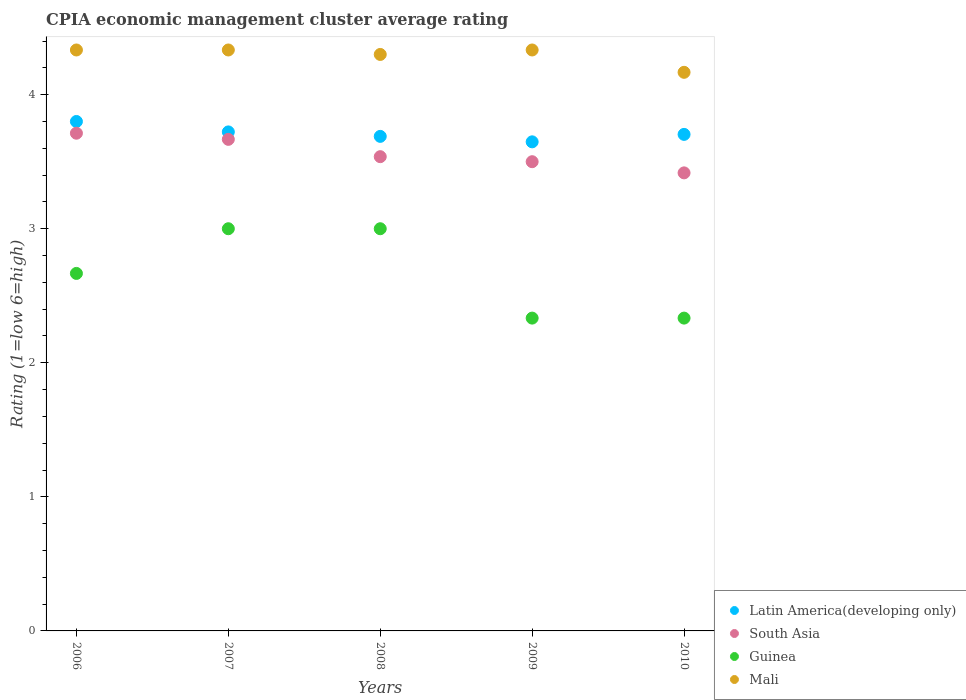How many different coloured dotlines are there?
Offer a very short reply. 4. What is the CPIA rating in Mali in 2006?
Offer a very short reply. 4.33. Across all years, what is the minimum CPIA rating in Mali?
Give a very brief answer. 4.17. In which year was the CPIA rating in Latin America(developing only) maximum?
Provide a short and direct response. 2006. What is the total CPIA rating in Guinea in the graph?
Ensure brevity in your answer.  13.33. What is the difference between the CPIA rating in Latin America(developing only) in 2006 and that in 2010?
Keep it short and to the point. 0.1. What is the difference between the CPIA rating in Guinea in 2007 and the CPIA rating in Latin America(developing only) in 2008?
Provide a succinct answer. -0.69. What is the average CPIA rating in Guinea per year?
Keep it short and to the point. 2.67. In the year 2007, what is the difference between the CPIA rating in Guinea and CPIA rating in South Asia?
Make the answer very short. -0.67. What is the ratio of the CPIA rating in Guinea in 2007 to that in 2009?
Your answer should be very brief. 1.29. What is the difference between the highest and the second highest CPIA rating in Latin America(developing only)?
Your answer should be compact. 0.08. What is the difference between the highest and the lowest CPIA rating in Latin America(developing only)?
Ensure brevity in your answer.  0.15. In how many years, is the CPIA rating in Guinea greater than the average CPIA rating in Guinea taken over all years?
Keep it short and to the point. 3. Is the sum of the CPIA rating in South Asia in 2007 and 2008 greater than the maximum CPIA rating in Guinea across all years?
Ensure brevity in your answer.  Yes. Is it the case that in every year, the sum of the CPIA rating in Mali and CPIA rating in South Asia  is greater than the sum of CPIA rating in Latin America(developing only) and CPIA rating in Guinea?
Ensure brevity in your answer.  Yes. Is the CPIA rating in Latin America(developing only) strictly greater than the CPIA rating in South Asia over the years?
Your answer should be very brief. Yes. What is the difference between two consecutive major ticks on the Y-axis?
Give a very brief answer. 1. Does the graph contain any zero values?
Provide a succinct answer. No. Does the graph contain grids?
Provide a succinct answer. No. How many legend labels are there?
Give a very brief answer. 4. How are the legend labels stacked?
Offer a terse response. Vertical. What is the title of the graph?
Keep it short and to the point. CPIA economic management cluster average rating. Does "Europe(all income levels)" appear as one of the legend labels in the graph?
Keep it short and to the point. No. What is the label or title of the X-axis?
Make the answer very short. Years. What is the Rating (1=low 6=high) of South Asia in 2006?
Your answer should be very brief. 3.71. What is the Rating (1=low 6=high) in Guinea in 2006?
Your answer should be very brief. 2.67. What is the Rating (1=low 6=high) of Mali in 2006?
Offer a terse response. 4.33. What is the Rating (1=low 6=high) in Latin America(developing only) in 2007?
Offer a terse response. 3.72. What is the Rating (1=low 6=high) of South Asia in 2007?
Provide a short and direct response. 3.67. What is the Rating (1=low 6=high) of Guinea in 2007?
Give a very brief answer. 3. What is the Rating (1=low 6=high) in Mali in 2007?
Offer a terse response. 4.33. What is the Rating (1=low 6=high) of Latin America(developing only) in 2008?
Provide a succinct answer. 3.69. What is the Rating (1=low 6=high) in South Asia in 2008?
Ensure brevity in your answer.  3.54. What is the Rating (1=low 6=high) in Guinea in 2008?
Provide a short and direct response. 3. What is the Rating (1=low 6=high) of Mali in 2008?
Your response must be concise. 4.3. What is the Rating (1=low 6=high) in Latin America(developing only) in 2009?
Offer a very short reply. 3.65. What is the Rating (1=low 6=high) of South Asia in 2009?
Provide a succinct answer. 3.5. What is the Rating (1=low 6=high) of Guinea in 2009?
Provide a succinct answer. 2.33. What is the Rating (1=low 6=high) of Mali in 2009?
Ensure brevity in your answer.  4.33. What is the Rating (1=low 6=high) in Latin America(developing only) in 2010?
Offer a very short reply. 3.7. What is the Rating (1=low 6=high) of South Asia in 2010?
Your answer should be very brief. 3.42. What is the Rating (1=low 6=high) in Guinea in 2010?
Your response must be concise. 2.33. What is the Rating (1=low 6=high) in Mali in 2010?
Offer a very short reply. 4.17. Across all years, what is the maximum Rating (1=low 6=high) in South Asia?
Your response must be concise. 3.71. Across all years, what is the maximum Rating (1=low 6=high) of Guinea?
Keep it short and to the point. 3. Across all years, what is the maximum Rating (1=low 6=high) in Mali?
Provide a succinct answer. 4.33. Across all years, what is the minimum Rating (1=low 6=high) of Latin America(developing only)?
Give a very brief answer. 3.65. Across all years, what is the minimum Rating (1=low 6=high) of South Asia?
Give a very brief answer. 3.42. Across all years, what is the minimum Rating (1=low 6=high) in Guinea?
Provide a succinct answer. 2.33. Across all years, what is the minimum Rating (1=low 6=high) of Mali?
Offer a terse response. 4.17. What is the total Rating (1=low 6=high) in Latin America(developing only) in the graph?
Give a very brief answer. 18.56. What is the total Rating (1=low 6=high) of South Asia in the graph?
Your response must be concise. 17.83. What is the total Rating (1=low 6=high) in Guinea in the graph?
Your response must be concise. 13.33. What is the total Rating (1=low 6=high) of Mali in the graph?
Your response must be concise. 21.47. What is the difference between the Rating (1=low 6=high) of Latin America(developing only) in 2006 and that in 2007?
Provide a short and direct response. 0.08. What is the difference between the Rating (1=low 6=high) of South Asia in 2006 and that in 2007?
Keep it short and to the point. 0.05. What is the difference between the Rating (1=low 6=high) in Guinea in 2006 and that in 2007?
Offer a terse response. -0.33. What is the difference between the Rating (1=low 6=high) of Latin America(developing only) in 2006 and that in 2008?
Your answer should be very brief. 0.11. What is the difference between the Rating (1=low 6=high) of South Asia in 2006 and that in 2008?
Keep it short and to the point. 0.17. What is the difference between the Rating (1=low 6=high) of Guinea in 2006 and that in 2008?
Offer a very short reply. -0.33. What is the difference between the Rating (1=low 6=high) of Latin America(developing only) in 2006 and that in 2009?
Your answer should be very brief. 0.15. What is the difference between the Rating (1=low 6=high) in South Asia in 2006 and that in 2009?
Give a very brief answer. 0.21. What is the difference between the Rating (1=low 6=high) in Mali in 2006 and that in 2009?
Offer a terse response. 0. What is the difference between the Rating (1=low 6=high) in Latin America(developing only) in 2006 and that in 2010?
Offer a very short reply. 0.1. What is the difference between the Rating (1=low 6=high) of South Asia in 2006 and that in 2010?
Offer a terse response. 0.3. What is the difference between the Rating (1=low 6=high) in Guinea in 2006 and that in 2010?
Offer a very short reply. 0.33. What is the difference between the Rating (1=low 6=high) in South Asia in 2007 and that in 2008?
Offer a very short reply. 0.13. What is the difference between the Rating (1=low 6=high) in Mali in 2007 and that in 2008?
Give a very brief answer. 0.03. What is the difference between the Rating (1=low 6=high) in Latin America(developing only) in 2007 and that in 2009?
Ensure brevity in your answer.  0.07. What is the difference between the Rating (1=low 6=high) in Mali in 2007 and that in 2009?
Give a very brief answer. 0. What is the difference between the Rating (1=low 6=high) of Latin America(developing only) in 2007 and that in 2010?
Keep it short and to the point. 0.02. What is the difference between the Rating (1=low 6=high) in Guinea in 2007 and that in 2010?
Provide a succinct answer. 0.67. What is the difference between the Rating (1=low 6=high) in Latin America(developing only) in 2008 and that in 2009?
Your response must be concise. 0.04. What is the difference between the Rating (1=low 6=high) in South Asia in 2008 and that in 2009?
Give a very brief answer. 0.04. What is the difference between the Rating (1=low 6=high) of Mali in 2008 and that in 2009?
Your answer should be compact. -0.03. What is the difference between the Rating (1=low 6=high) in Latin America(developing only) in 2008 and that in 2010?
Keep it short and to the point. -0.01. What is the difference between the Rating (1=low 6=high) of South Asia in 2008 and that in 2010?
Your answer should be very brief. 0.12. What is the difference between the Rating (1=low 6=high) of Guinea in 2008 and that in 2010?
Provide a succinct answer. 0.67. What is the difference between the Rating (1=low 6=high) of Mali in 2008 and that in 2010?
Your response must be concise. 0.13. What is the difference between the Rating (1=low 6=high) of Latin America(developing only) in 2009 and that in 2010?
Make the answer very short. -0.06. What is the difference between the Rating (1=low 6=high) in South Asia in 2009 and that in 2010?
Make the answer very short. 0.08. What is the difference between the Rating (1=low 6=high) of Latin America(developing only) in 2006 and the Rating (1=low 6=high) of South Asia in 2007?
Provide a succinct answer. 0.13. What is the difference between the Rating (1=low 6=high) of Latin America(developing only) in 2006 and the Rating (1=low 6=high) of Guinea in 2007?
Provide a short and direct response. 0.8. What is the difference between the Rating (1=low 6=high) of Latin America(developing only) in 2006 and the Rating (1=low 6=high) of Mali in 2007?
Ensure brevity in your answer.  -0.53. What is the difference between the Rating (1=low 6=high) in South Asia in 2006 and the Rating (1=low 6=high) in Guinea in 2007?
Ensure brevity in your answer.  0.71. What is the difference between the Rating (1=low 6=high) in South Asia in 2006 and the Rating (1=low 6=high) in Mali in 2007?
Give a very brief answer. -0.62. What is the difference between the Rating (1=low 6=high) in Guinea in 2006 and the Rating (1=low 6=high) in Mali in 2007?
Keep it short and to the point. -1.67. What is the difference between the Rating (1=low 6=high) in Latin America(developing only) in 2006 and the Rating (1=low 6=high) in South Asia in 2008?
Keep it short and to the point. 0.26. What is the difference between the Rating (1=low 6=high) in Latin America(developing only) in 2006 and the Rating (1=low 6=high) in Guinea in 2008?
Offer a very short reply. 0.8. What is the difference between the Rating (1=low 6=high) in Latin America(developing only) in 2006 and the Rating (1=low 6=high) in Mali in 2008?
Offer a terse response. -0.5. What is the difference between the Rating (1=low 6=high) in South Asia in 2006 and the Rating (1=low 6=high) in Guinea in 2008?
Ensure brevity in your answer.  0.71. What is the difference between the Rating (1=low 6=high) of South Asia in 2006 and the Rating (1=low 6=high) of Mali in 2008?
Your answer should be compact. -0.59. What is the difference between the Rating (1=low 6=high) in Guinea in 2006 and the Rating (1=low 6=high) in Mali in 2008?
Make the answer very short. -1.63. What is the difference between the Rating (1=low 6=high) in Latin America(developing only) in 2006 and the Rating (1=low 6=high) in Guinea in 2009?
Make the answer very short. 1.47. What is the difference between the Rating (1=low 6=high) of Latin America(developing only) in 2006 and the Rating (1=low 6=high) of Mali in 2009?
Offer a terse response. -0.53. What is the difference between the Rating (1=low 6=high) of South Asia in 2006 and the Rating (1=low 6=high) of Guinea in 2009?
Make the answer very short. 1.38. What is the difference between the Rating (1=low 6=high) in South Asia in 2006 and the Rating (1=low 6=high) in Mali in 2009?
Provide a succinct answer. -0.62. What is the difference between the Rating (1=low 6=high) of Guinea in 2006 and the Rating (1=low 6=high) of Mali in 2009?
Your response must be concise. -1.67. What is the difference between the Rating (1=low 6=high) of Latin America(developing only) in 2006 and the Rating (1=low 6=high) of South Asia in 2010?
Offer a terse response. 0.38. What is the difference between the Rating (1=low 6=high) of Latin America(developing only) in 2006 and the Rating (1=low 6=high) of Guinea in 2010?
Keep it short and to the point. 1.47. What is the difference between the Rating (1=low 6=high) of Latin America(developing only) in 2006 and the Rating (1=low 6=high) of Mali in 2010?
Offer a terse response. -0.37. What is the difference between the Rating (1=low 6=high) of South Asia in 2006 and the Rating (1=low 6=high) of Guinea in 2010?
Ensure brevity in your answer.  1.38. What is the difference between the Rating (1=low 6=high) in South Asia in 2006 and the Rating (1=low 6=high) in Mali in 2010?
Your response must be concise. -0.45. What is the difference between the Rating (1=low 6=high) in Latin America(developing only) in 2007 and the Rating (1=low 6=high) in South Asia in 2008?
Your answer should be very brief. 0.18. What is the difference between the Rating (1=low 6=high) of Latin America(developing only) in 2007 and the Rating (1=low 6=high) of Guinea in 2008?
Offer a terse response. 0.72. What is the difference between the Rating (1=low 6=high) in Latin America(developing only) in 2007 and the Rating (1=low 6=high) in Mali in 2008?
Keep it short and to the point. -0.58. What is the difference between the Rating (1=low 6=high) of South Asia in 2007 and the Rating (1=low 6=high) of Mali in 2008?
Your response must be concise. -0.63. What is the difference between the Rating (1=low 6=high) of Latin America(developing only) in 2007 and the Rating (1=low 6=high) of South Asia in 2009?
Offer a very short reply. 0.22. What is the difference between the Rating (1=low 6=high) of Latin America(developing only) in 2007 and the Rating (1=low 6=high) of Guinea in 2009?
Offer a very short reply. 1.39. What is the difference between the Rating (1=low 6=high) of Latin America(developing only) in 2007 and the Rating (1=low 6=high) of Mali in 2009?
Offer a very short reply. -0.61. What is the difference between the Rating (1=low 6=high) of South Asia in 2007 and the Rating (1=low 6=high) of Mali in 2009?
Your response must be concise. -0.67. What is the difference between the Rating (1=low 6=high) of Guinea in 2007 and the Rating (1=low 6=high) of Mali in 2009?
Give a very brief answer. -1.33. What is the difference between the Rating (1=low 6=high) in Latin America(developing only) in 2007 and the Rating (1=low 6=high) in South Asia in 2010?
Your response must be concise. 0.31. What is the difference between the Rating (1=low 6=high) in Latin America(developing only) in 2007 and the Rating (1=low 6=high) in Guinea in 2010?
Provide a succinct answer. 1.39. What is the difference between the Rating (1=low 6=high) in Latin America(developing only) in 2007 and the Rating (1=low 6=high) in Mali in 2010?
Your response must be concise. -0.44. What is the difference between the Rating (1=low 6=high) in South Asia in 2007 and the Rating (1=low 6=high) in Mali in 2010?
Your response must be concise. -0.5. What is the difference between the Rating (1=low 6=high) of Guinea in 2007 and the Rating (1=low 6=high) of Mali in 2010?
Ensure brevity in your answer.  -1.17. What is the difference between the Rating (1=low 6=high) in Latin America(developing only) in 2008 and the Rating (1=low 6=high) in South Asia in 2009?
Your response must be concise. 0.19. What is the difference between the Rating (1=low 6=high) in Latin America(developing only) in 2008 and the Rating (1=low 6=high) in Guinea in 2009?
Your response must be concise. 1.36. What is the difference between the Rating (1=low 6=high) in Latin America(developing only) in 2008 and the Rating (1=low 6=high) in Mali in 2009?
Offer a very short reply. -0.64. What is the difference between the Rating (1=low 6=high) of South Asia in 2008 and the Rating (1=low 6=high) of Guinea in 2009?
Make the answer very short. 1.2. What is the difference between the Rating (1=low 6=high) of South Asia in 2008 and the Rating (1=low 6=high) of Mali in 2009?
Provide a succinct answer. -0.8. What is the difference between the Rating (1=low 6=high) in Guinea in 2008 and the Rating (1=low 6=high) in Mali in 2009?
Your response must be concise. -1.33. What is the difference between the Rating (1=low 6=high) of Latin America(developing only) in 2008 and the Rating (1=low 6=high) of South Asia in 2010?
Make the answer very short. 0.27. What is the difference between the Rating (1=low 6=high) in Latin America(developing only) in 2008 and the Rating (1=low 6=high) in Guinea in 2010?
Ensure brevity in your answer.  1.36. What is the difference between the Rating (1=low 6=high) in Latin America(developing only) in 2008 and the Rating (1=low 6=high) in Mali in 2010?
Your response must be concise. -0.48. What is the difference between the Rating (1=low 6=high) of South Asia in 2008 and the Rating (1=low 6=high) of Guinea in 2010?
Offer a very short reply. 1.2. What is the difference between the Rating (1=low 6=high) in South Asia in 2008 and the Rating (1=low 6=high) in Mali in 2010?
Your response must be concise. -0.63. What is the difference between the Rating (1=low 6=high) of Guinea in 2008 and the Rating (1=low 6=high) of Mali in 2010?
Your answer should be compact. -1.17. What is the difference between the Rating (1=low 6=high) of Latin America(developing only) in 2009 and the Rating (1=low 6=high) of South Asia in 2010?
Your response must be concise. 0.23. What is the difference between the Rating (1=low 6=high) of Latin America(developing only) in 2009 and the Rating (1=low 6=high) of Guinea in 2010?
Your answer should be very brief. 1.31. What is the difference between the Rating (1=low 6=high) of Latin America(developing only) in 2009 and the Rating (1=low 6=high) of Mali in 2010?
Your answer should be very brief. -0.52. What is the difference between the Rating (1=low 6=high) in South Asia in 2009 and the Rating (1=low 6=high) in Guinea in 2010?
Make the answer very short. 1.17. What is the difference between the Rating (1=low 6=high) of Guinea in 2009 and the Rating (1=low 6=high) of Mali in 2010?
Your answer should be compact. -1.83. What is the average Rating (1=low 6=high) of Latin America(developing only) per year?
Your answer should be compact. 3.71. What is the average Rating (1=low 6=high) in South Asia per year?
Provide a succinct answer. 3.57. What is the average Rating (1=low 6=high) of Guinea per year?
Ensure brevity in your answer.  2.67. What is the average Rating (1=low 6=high) of Mali per year?
Your answer should be very brief. 4.29. In the year 2006, what is the difference between the Rating (1=low 6=high) of Latin America(developing only) and Rating (1=low 6=high) of South Asia?
Ensure brevity in your answer.  0.09. In the year 2006, what is the difference between the Rating (1=low 6=high) of Latin America(developing only) and Rating (1=low 6=high) of Guinea?
Provide a short and direct response. 1.13. In the year 2006, what is the difference between the Rating (1=low 6=high) in Latin America(developing only) and Rating (1=low 6=high) in Mali?
Provide a short and direct response. -0.53. In the year 2006, what is the difference between the Rating (1=low 6=high) in South Asia and Rating (1=low 6=high) in Guinea?
Offer a terse response. 1.05. In the year 2006, what is the difference between the Rating (1=low 6=high) in South Asia and Rating (1=low 6=high) in Mali?
Provide a succinct answer. -0.62. In the year 2006, what is the difference between the Rating (1=low 6=high) in Guinea and Rating (1=low 6=high) in Mali?
Provide a succinct answer. -1.67. In the year 2007, what is the difference between the Rating (1=low 6=high) of Latin America(developing only) and Rating (1=low 6=high) of South Asia?
Ensure brevity in your answer.  0.06. In the year 2007, what is the difference between the Rating (1=low 6=high) in Latin America(developing only) and Rating (1=low 6=high) in Guinea?
Keep it short and to the point. 0.72. In the year 2007, what is the difference between the Rating (1=low 6=high) of Latin America(developing only) and Rating (1=low 6=high) of Mali?
Your response must be concise. -0.61. In the year 2007, what is the difference between the Rating (1=low 6=high) in South Asia and Rating (1=low 6=high) in Mali?
Keep it short and to the point. -0.67. In the year 2007, what is the difference between the Rating (1=low 6=high) of Guinea and Rating (1=low 6=high) of Mali?
Offer a terse response. -1.33. In the year 2008, what is the difference between the Rating (1=low 6=high) of Latin America(developing only) and Rating (1=low 6=high) of South Asia?
Ensure brevity in your answer.  0.15. In the year 2008, what is the difference between the Rating (1=low 6=high) in Latin America(developing only) and Rating (1=low 6=high) in Guinea?
Give a very brief answer. 0.69. In the year 2008, what is the difference between the Rating (1=low 6=high) in Latin America(developing only) and Rating (1=low 6=high) in Mali?
Ensure brevity in your answer.  -0.61. In the year 2008, what is the difference between the Rating (1=low 6=high) in South Asia and Rating (1=low 6=high) in Guinea?
Make the answer very short. 0.54. In the year 2008, what is the difference between the Rating (1=low 6=high) of South Asia and Rating (1=low 6=high) of Mali?
Provide a succinct answer. -0.76. In the year 2008, what is the difference between the Rating (1=low 6=high) of Guinea and Rating (1=low 6=high) of Mali?
Offer a terse response. -1.3. In the year 2009, what is the difference between the Rating (1=low 6=high) of Latin America(developing only) and Rating (1=low 6=high) of South Asia?
Your answer should be very brief. 0.15. In the year 2009, what is the difference between the Rating (1=low 6=high) of Latin America(developing only) and Rating (1=low 6=high) of Guinea?
Offer a very short reply. 1.31. In the year 2009, what is the difference between the Rating (1=low 6=high) in Latin America(developing only) and Rating (1=low 6=high) in Mali?
Offer a very short reply. -0.69. In the year 2009, what is the difference between the Rating (1=low 6=high) in South Asia and Rating (1=low 6=high) in Guinea?
Ensure brevity in your answer.  1.17. In the year 2009, what is the difference between the Rating (1=low 6=high) in Guinea and Rating (1=low 6=high) in Mali?
Offer a terse response. -2. In the year 2010, what is the difference between the Rating (1=low 6=high) of Latin America(developing only) and Rating (1=low 6=high) of South Asia?
Offer a very short reply. 0.29. In the year 2010, what is the difference between the Rating (1=low 6=high) of Latin America(developing only) and Rating (1=low 6=high) of Guinea?
Your answer should be compact. 1.37. In the year 2010, what is the difference between the Rating (1=low 6=high) of Latin America(developing only) and Rating (1=low 6=high) of Mali?
Keep it short and to the point. -0.46. In the year 2010, what is the difference between the Rating (1=low 6=high) in South Asia and Rating (1=low 6=high) in Mali?
Your answer should be compact. -0.75. In the year 2010, what is the difference between the Rating (1=low 6=high) in Guinea and Rating (1=low 6=high) in Mali?
Offer a terse response. -1.83. What is the ratio of the Rating (1=low 6=high) of Latin America(developing only) in 2006 to that in 2007?
Offer a terse response. 1.02. What is the ratio of the Rating (1=low 6=high) in South Asia in 2006 to that in 2007?
Keep it short and to the point. 1.01. What is the ratio of the Rating (1=low 6=high) in Mali in 2006 to that in 2007?
Offer a terse response. 1. What is the ratio of the Rating (1=low 6=high) in Latin America(developing only) in 2006 to that in 2008?
Offer a terse response. 1.03. What is the ratio of the Rating (1=low 6=high) of South Asia in 2006 to that in 2008?
Give a very brief answer. 1.05. What is the ratio of the Rating (1=low 6=high) in Mali in 2006 to that in 2008?
Your response must be concise. 1.01. What is the ratio of the Rating (1=low 6=high) of Latin America(developing only) in 2006 to that in 2009?
Make the answer very short. 1.04. What is the ratio of the Rating (1=low 6=high) of South Asia in 2006 to that in 2009?
Provide a short and direct response. 1.06. What is the ratio of the Rating (1=low 6=high) of Guinea in 2006 to that in 2009?
Give a very brief answer. 1.14. What is the ratio of the Rating (1=low 6=high) in Mali in 2006 to that in 2009?
Offer a terse response. 1. What is the ratio of the Rating (1=low 6=high) of Latin America(developing only) in 2006 to that in 2010?
Your answer should be compact. 1.03. What is the ratio of the Rating (1=low 6=high) in South Asia in 2006 to that in 2010?
Give a very brief answer. 1.09. What is the ratio of the Rating (1=low 6=high) of Latin America(developing only) in 2007 to that in 2008?
Keep it short and to the point. 1.01. What is the ratio of the Rating (1=low 6=high) in South Asia in 2007 to that in 2008?
Ensure brevity in your answer.  1.04. What is the ratio of the Rating (1=low 6=high) in Latin America(developing only) in 2007 to that in 2009?
Provide a short and direct response. 1.02. What is the ratio of the Rating (1=low 6=high) in South Asia in 2007 to that in 2009?
Your answer should be compact. 1.05. What is the ratio of the Rating (1=low 6=high) in Guinea in 2007 to that in 2009?
Keep it short and to the point. 1.29. What is the ratio of the Rating (1=low 6=high) in Latin America(developing only) in 2007 to that in 2010?
Provide a succinct answer. 1. What is the ratio of the Rating (1=low 6=high) in South Asia in 2007 to that in 2010?
Your answer should be very brief. 1.07. What is the ratio of the Rating (1=low 6=high) in Latin America(developing only) in 2008 to that in 2009?
Make the answer very short. 1.01. What is the ratio of the Rating (1=low 6=high) in South Asia in 2008 to that in 2009?
Your response must be concise. 1.01. What is the ratio of the Rating (1=low 6=high) of Mali in 2008 to that in 2009?
Your answer should be very brief. 0.99. What is the ratio of the Rating (1=low 6=high) of South Asia in 2008 to that in 2010?
Give a very brief answer. 1.04. What is the ratio of the Rating (1=low 6=high) of Mali in 2008 to that in 2010?
Your response must be concise. 1.03. What is the ratio of the Rating (1=low 6=high) of South Asia in 2009 to that in 2010?
Provide a succinct answer. 1.02. What is the ratio of the Rating (1=low 6=high) in Guinea in 2009 to that in 2010?
Your response must be concise. 1. What is the ratio of the Rating (1=low 6=high) of Mali in 2009 to that in 2010?
Keep it short and to the point. 1.04. What is the difference between the highest and the second highest Rating (1=low 6=high) in Latin America(developing only)?
Your answer should be compact. 0.08. What is the difference between the highest and the second highest Rating (1=low 6=high) in South Asia?
Provide a succinct answer. 0.05. What is the difference between the highest and the second highest Rating (1=low 6=high) of Guinea?
Offer a terse response. 0. What is the difference between the highest and the second highest Rating (1=low 6=high) of Mali?
Provide a short and direct response. 0. What is the difference between the highest and the lowest Rating (1=low 6=high) of Latin America(developing only)?
Keep it short and to the point. 0.15. What is the difference between the highest and the lowest Rating (1=low 6=high) of South Asia?
Provide a succinct answer. 0.3. What is the difference between the highest and the lowest Rating (1=low 6=high) in Mali?
Your response must be concise. 0.17. 